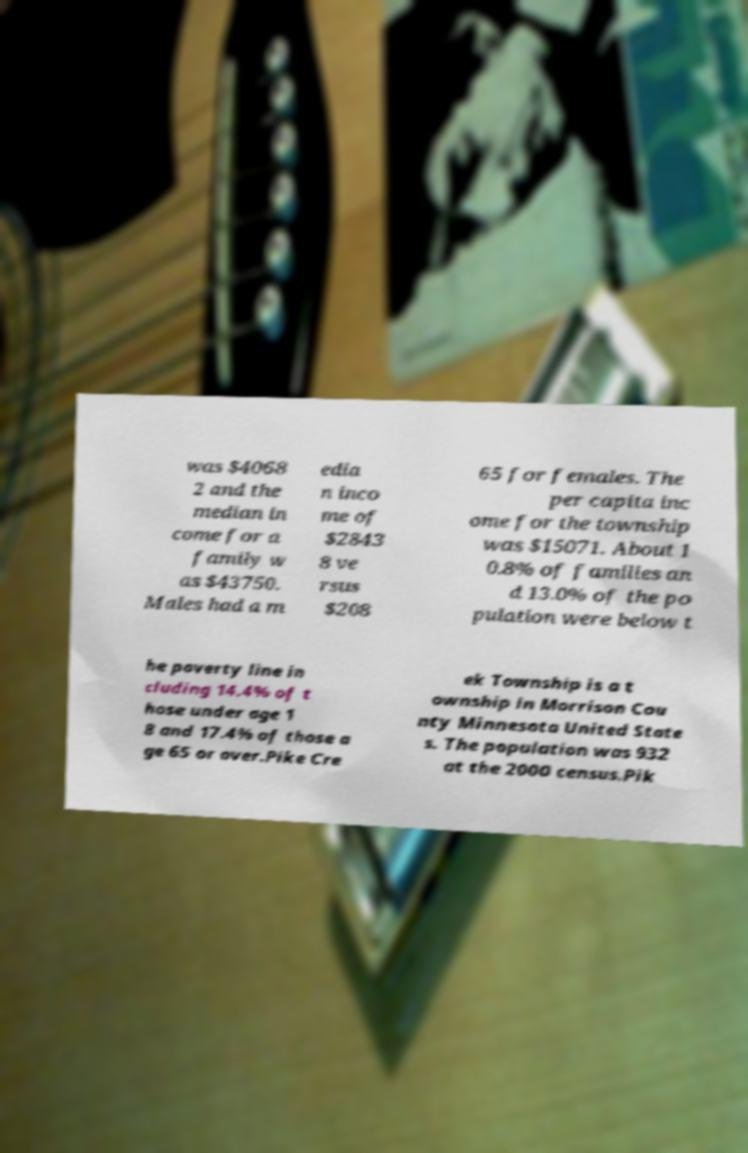Could you assist in decoding the text presented in this image and type it out clearly? was $4068 2 and the median in come for a family w as $43750. Males had a m edia n inco me of $2843 8 ve rsus $208 65 for females. The per capita inc ome for the township was $15071. About 1 0.8% of families an d 13.0% of the po pulation were below t he poverty line in cluding 14.4% of t hose under age 1 8 and 17.4% of those a ge 65 or over.Pike Cre ek Township is a t ownship in Morrison Cou nty Minnesota United State s. The population was 932 at the 2000 census.Pik 